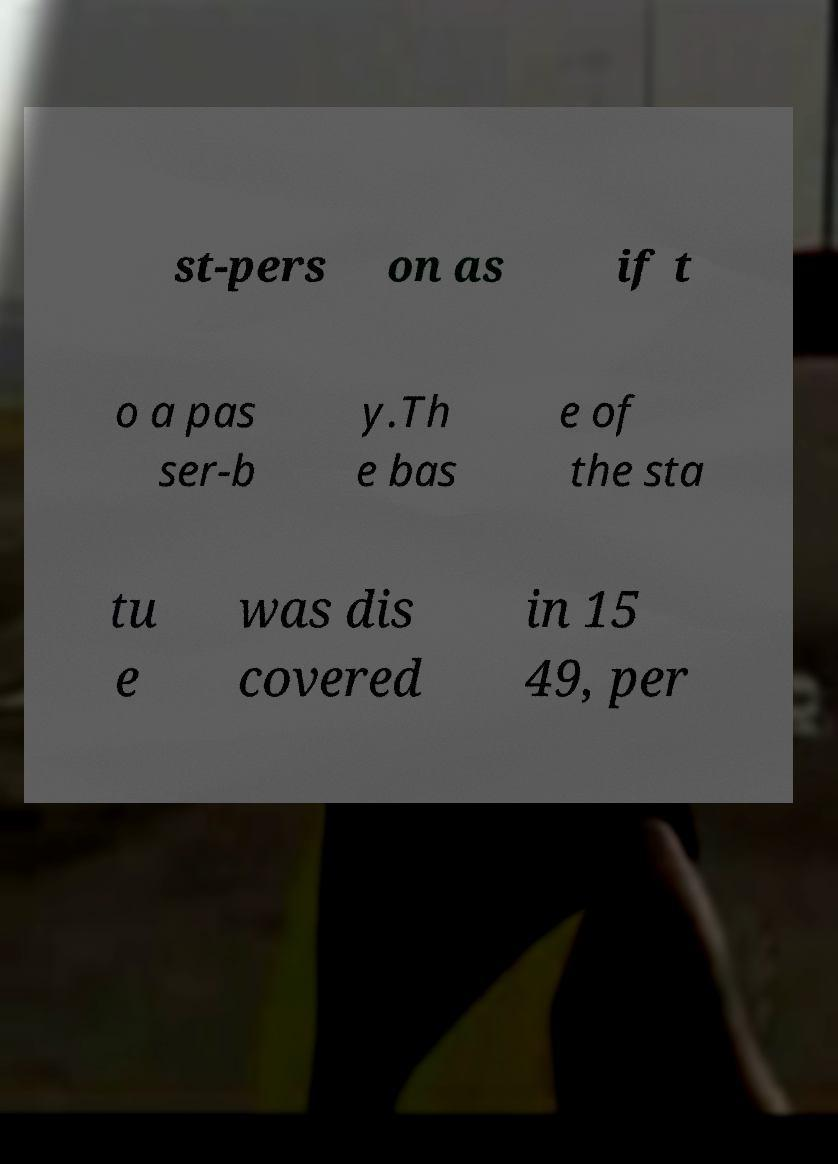Can you read and provide the text displayed in the image?This photo seems to have some interesting text. Can you extract and type it out for me? st-pers on as if t o a pas ser-b y.Th e bas e of the sta tu e was dis covered in 15 49, per 